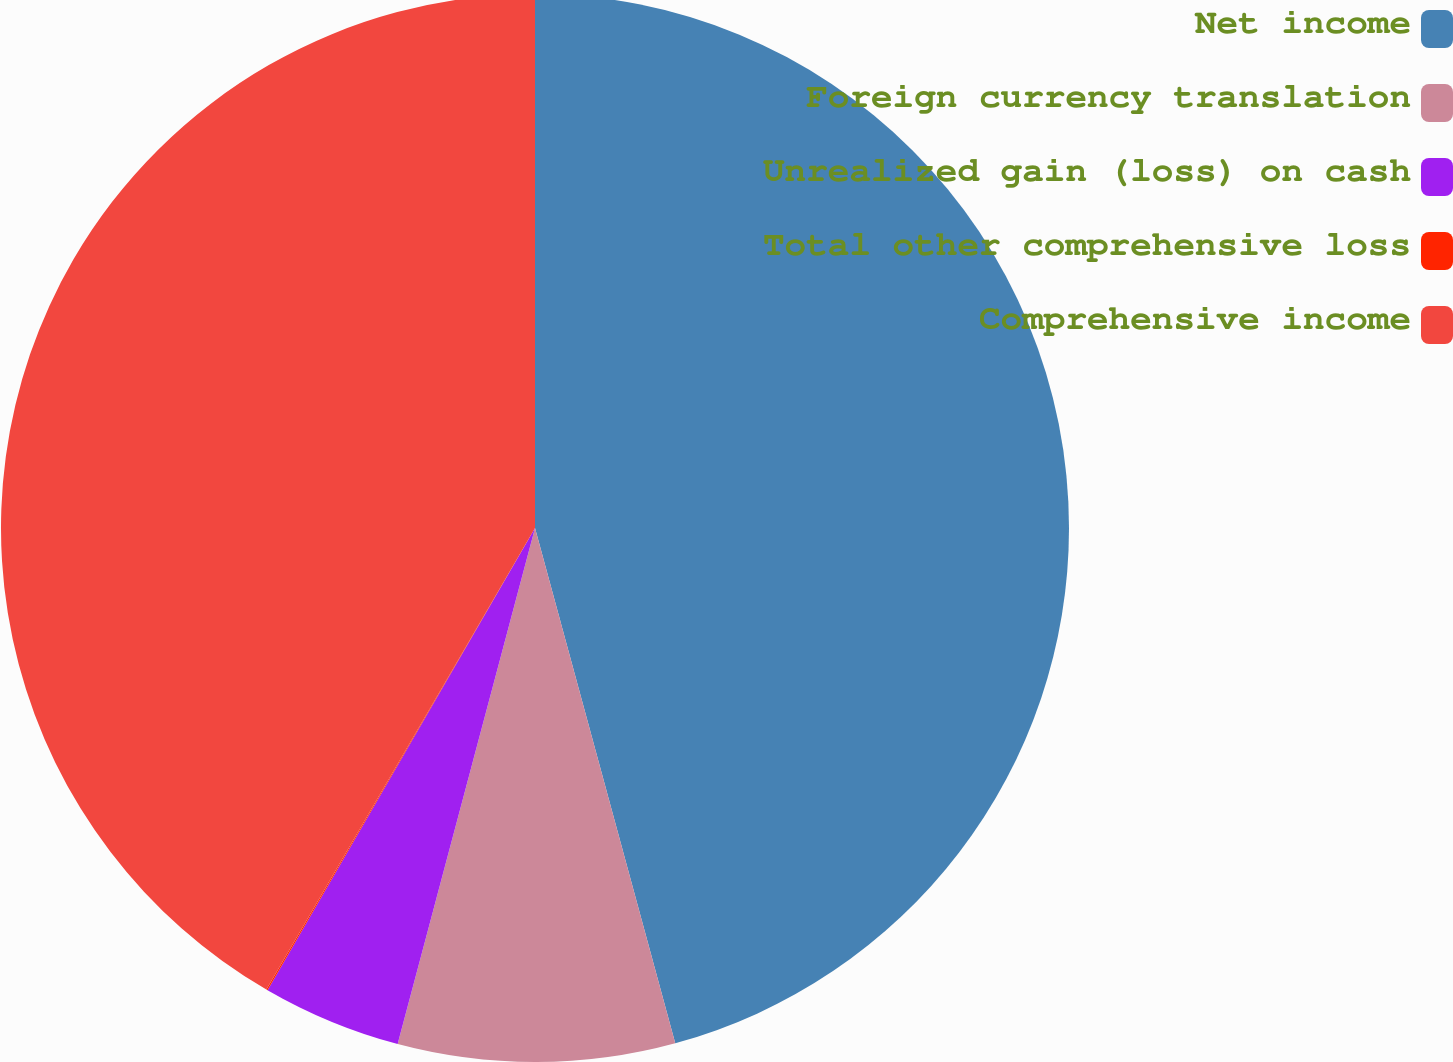Convert chart. <chart><loc_0><loc_0><loc_500><loc_500><pie_chart><fcel>Net income<fcel>Foreign currency translation<fcel>Unrealized gain (loss) on cash<fcel>Total other comprehensive loss<fcel>Comprehensive income<nl><fcel>45.77%<fcel>8.37%<fcel>4.21%<fcel>0.04%<fcel>41.61%<nl></chart> 